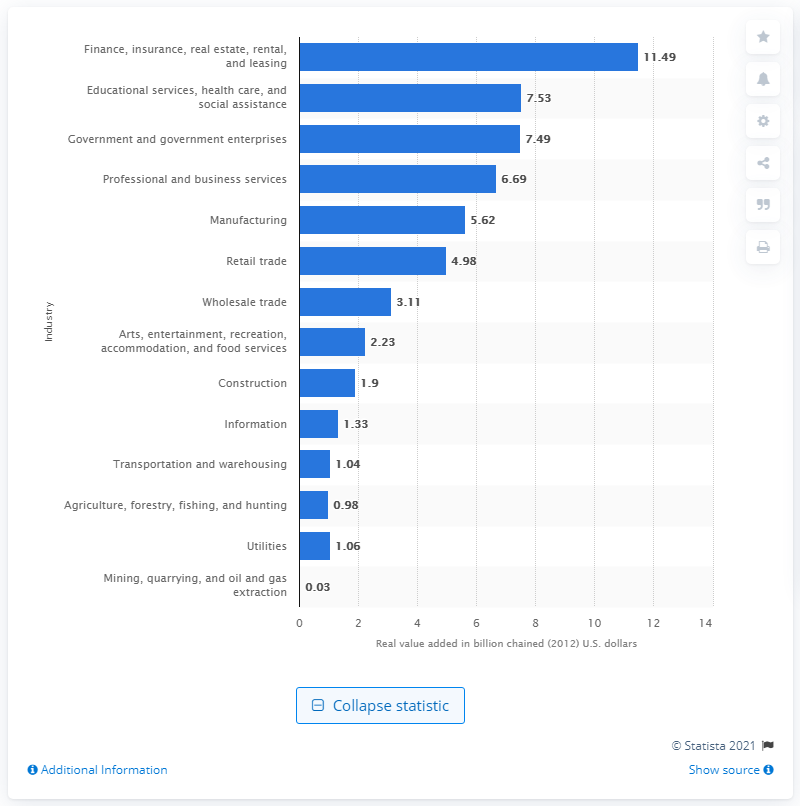Specify some key components in this picture. In 2012, the finance, insurance, real estate, rental, and leasing industry contributed 11.49% to the gross domestic product (GDP) of Maine. 